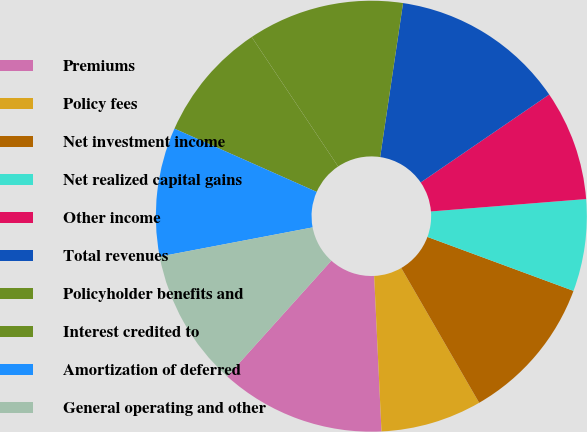Convert chart. <chart><loc_0><loc_0><loc_500><loc_500><pie_chart><fcel>Premiums<fcel>Policy fees<fcel>Net investment income<fcel>Net realized capital gains<fcel>Other income<fcel>Total revenues<fcel>Policyholder benefits and<fcel>Interest credited to<fcel>Amortization of deferred<fcel>General operating and other<nl><fcel>12.41%<fcel>7.59%<fcel>11.03%<fcel>6.9%<fcel>8.28%<fcel>13.1%<fcel>11.72%<fcel>8.97%<fcel>9.66%<fcel>10.34%<nl></chart> 